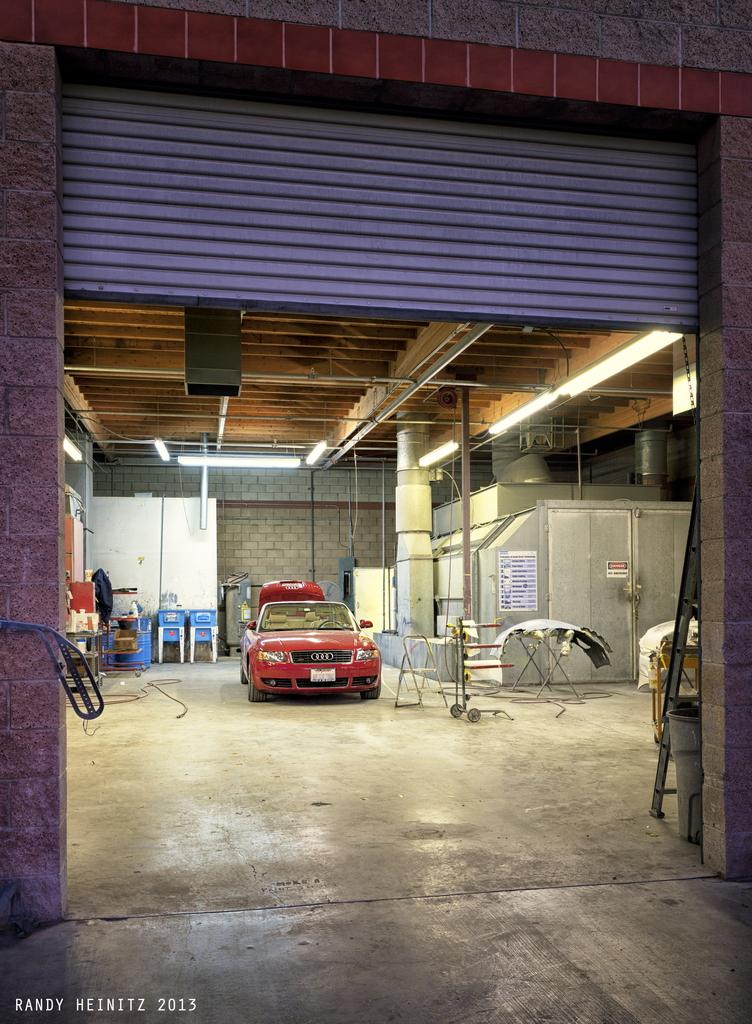What color is the vehicle in the image? The vehicle in the image is red. What type of furniture can be seen in the background? There are two blue chairs in the background. What color is the wall in the background? The wall in the background is white. What can be used for illumination in the image? There are lights visible in the image. What type of teeth can be seen in the image? There are no teeth visible in the image. What type of iron object is present in the image? There is no iron object present in the image. 